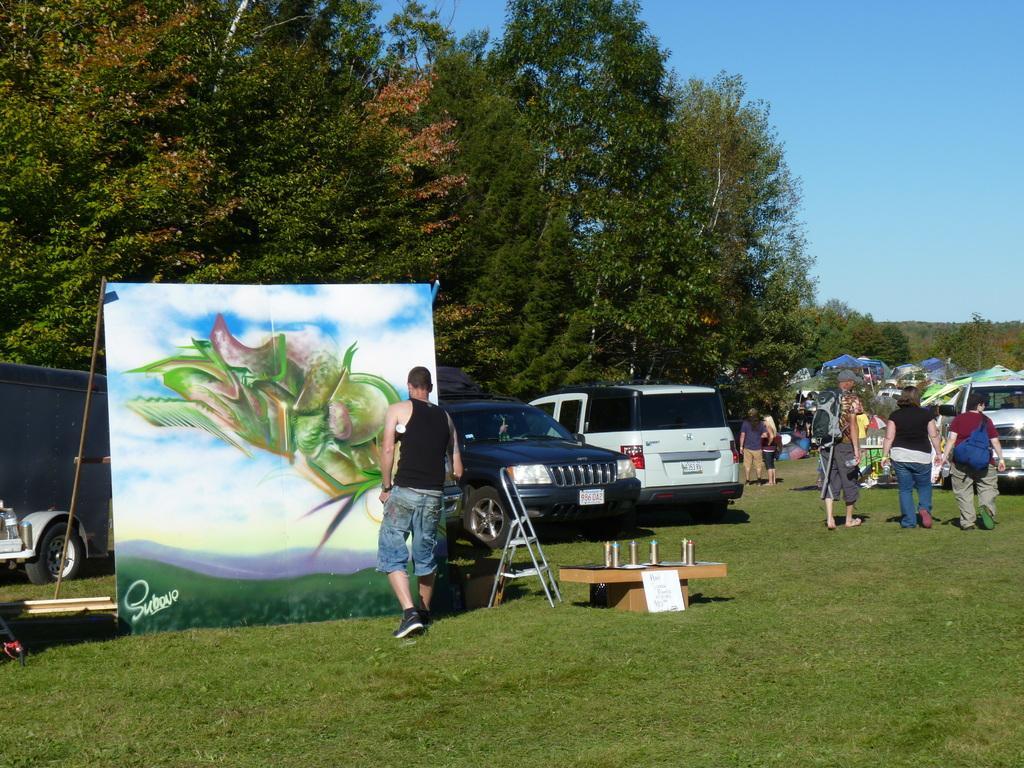How would you summarize this image in a sentence or two? In this image, on the left side, we can see a man standing in front of the painting. In the middle of the image, we can see a table with some water bottles and a board, ladder. On the right side, we can see a group of people, vehicle, tent, trees. In the background, we can see some vehicles which are placed on the grass, trees. At the top, we can see a sky, at the bottom, we can see a grass. 